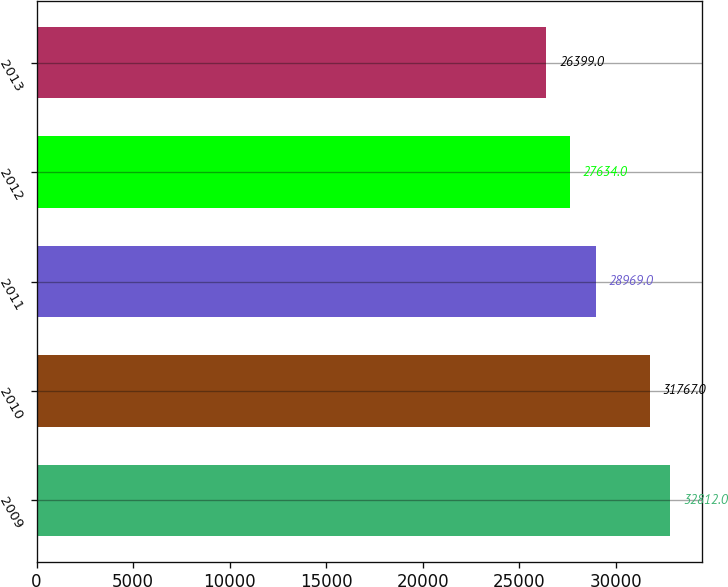<chart> <loc_0><loc_0><loc_500><loc_500><bar_chart><fcel>2009<fcel>2010<fcel>2011<fcel>2012<fcel>2013<nl><fcel>32812<fcel>31767<fcel>28969<fcel>27634<fcel>26399<nl></chart> 